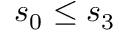<formula> <loc_0><loc_0><loc_500><loc_500>s _ { 0 } \leq s _ { 3 }</formula> 